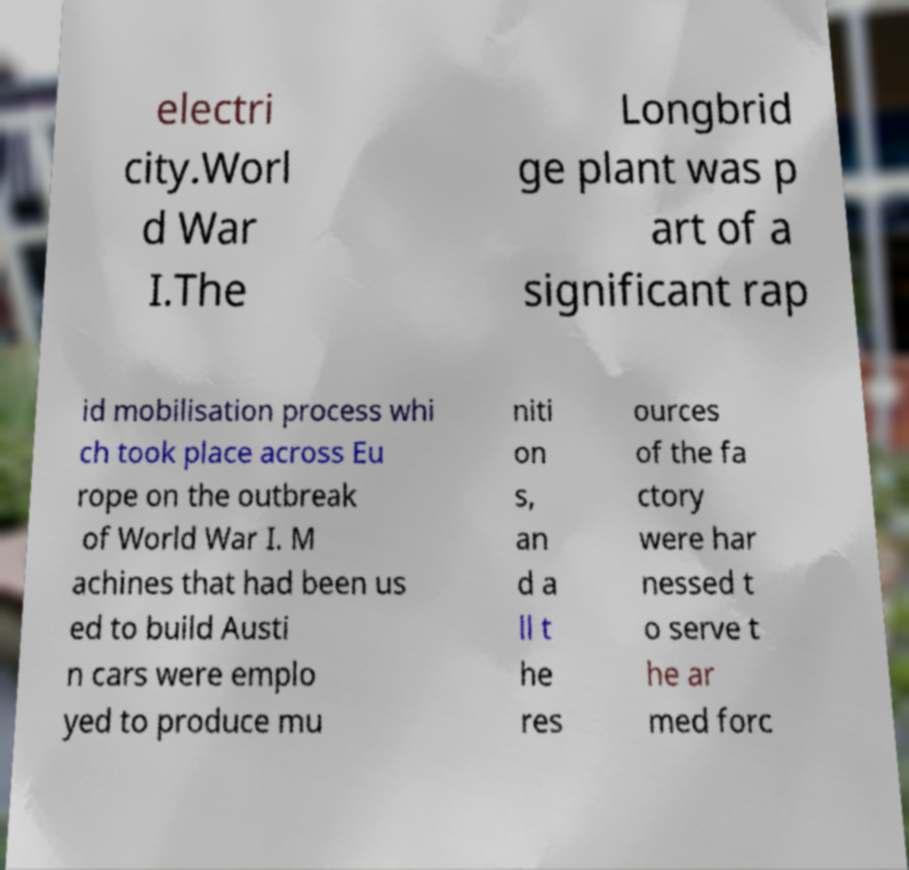For documentation purposes, I need the text within this image transcribed. Could you provide that? electri city.Worl d War I.The Longbrid ge plant was p art of a significant rap id mobilisation process whi ch took place across Eu rope on the outbreak of World War I. M achines that had been us ed to build Austi n cars were emplo yed to produce mu niti on s, an d a ll t he res ources of the fa ctory were har nessed t o serve t he ar med forc 